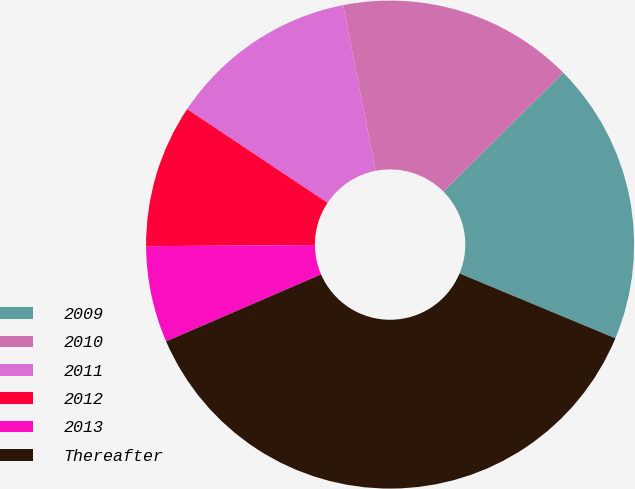Convert chart to OTSL. <chart><loc_0><loc_0><loc_500><loc_500><pie_chart><fcel>2009<fcel>2010<fcel>2011<fcel>2012<fcel>2013<fcel>Thereafter<nl><fcel>18.72%<fcel>15.64%<fcel>12.55%<fcel>9.47%<fcel>6.39%<fcel>37.23%<nl></chart> 